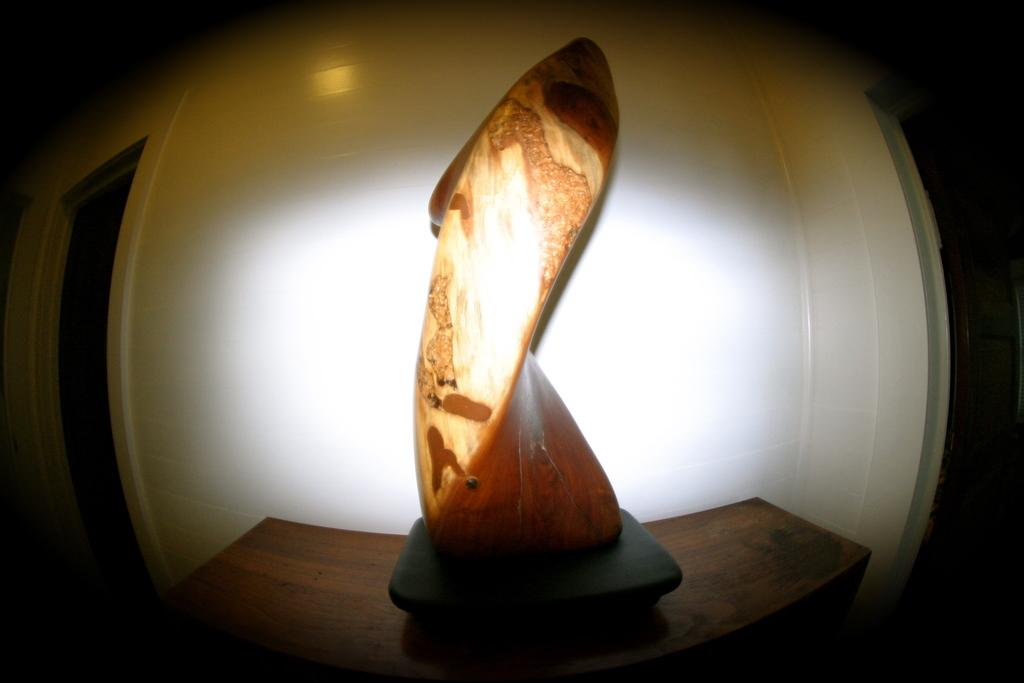What is the main subject of the image? There is an object in the middle of the image. Can you describe the surface on which the object is placed? The object is on a wooden surface. What can be seen in the background of the image? There is a white wall in the background of the image. What type of jam is being spread on the turkey's tail in the image? There is no jam, turkey, or tail present in the image. 